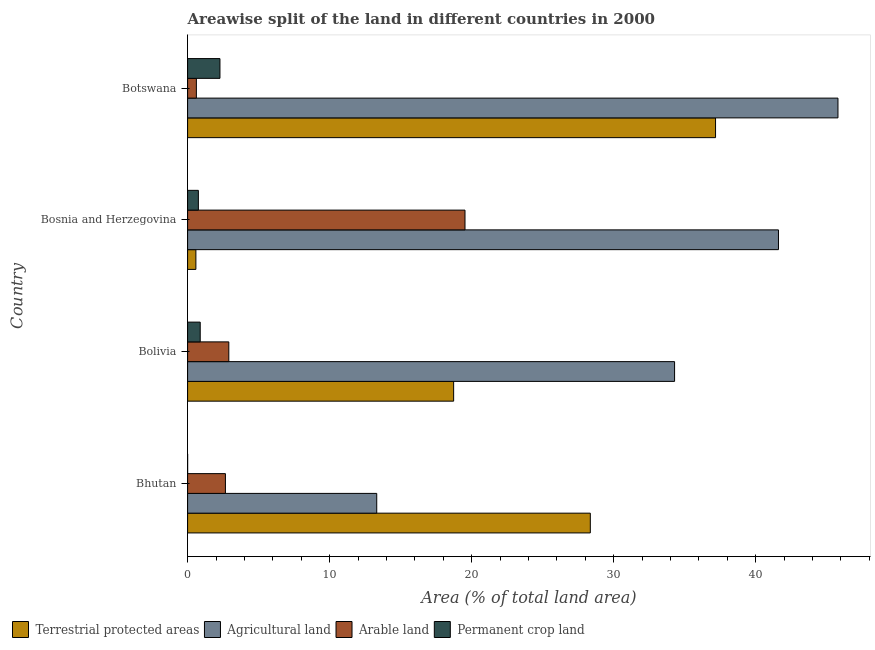How many different coloured bars are there?
Offer a terse response. 4. Are the number of bars on each tick of the Y-axis equal?
Keep it short and to the point. Yes. How many bars are there on the 1st tick from the top?
Ensure brevity in your answer.  4. How many bars are there on the 3rd tick from the bottom?
Your response must be concise. 4. What is the label of the 4th group of bars from the top?
Offer a terse response. Bhutan. In how many cases, is the number of bars for a given country not equal to the number of legend labels?
Provide a short and direct response. 0. What is the percentage of area under agricultural land in Bhutan?
Your answer should be compact. 13.32. Across all countries, what is the maximum percentage of area under permanent crop land?
Your answer should be very brief. 2.28. Across all countries, what is the minimum percentage of area under permanent crop land?
Your answer should be compact. 0. In which country was the percentage of area under arable land maximum?
Keep it short and to the point. Bosnia and Herzegovina. In which country was the percentage of area under agricultural land minimum?
Ensure brevity in your answer.  Bhutan. What is the total percentage of area under agricultural land in the graph?
Keep it short and to the point. 135. What is the difference between the percentage of area under agricultural land in Bolivia and that in Bosnia and Herzegovina?
Your answer should be compact. -7.32. What is the difference between the percentage of area under agricultural land in Bosnia and Herzegovina and the percentage of area under arable land in Bolivia?
Provide a succinct answer. 38.7. What is the average percentage of area under arable land per country?
Your answer should be compact. 6.43. What is the difference between the percentage of land under terrestrial protection and percentage of area under arable land in Bolivia?
Your answer should be very brief. 15.83. What is the ratio of the percentage of land under terrestrial protection in Bolivia to that in Botswana?
Give a very brief answer. 0.5. Is the percentage of area under agricultural land in Bolivia less than that in Bosnia and Herzegovina?
Give a very brief answer. Yes. What is the difference between the highest and the second highest percentage of area under agricultural land?
Offer a very short reply. 4.19. What is the difference between the highest and the lowest percentage of area under arable land?
Give a very brief answer. 18.91. Is the sum of the percentage of area under arable land in Bolivia and Bosnia and Herzegovina greater than the maximum percentage of land under terrestrial protection across all countries?
Ensure brevity in your answer.  No. What does the 2nd bar from the top in Bolivia represents?
Offer a terse response. Arable land. What does the 4th bar from the bottom in Bhutan represents?
Provide a succinct answer. Permanent crop land. Are all the bars in the graph horizontal?
Keep it short and to the point. Yes. Are the values on the major ticks of X-axis written in scientific E-notation?
Provide a succinct answer. No. What is the title of the graph?
Make the answer very short. Areawise split of the land in different countries in 2000. What is the label or title of the X-axis?
Make the answer very short. Area (% of total land area). What is the Area (% of total land area) in Terrestrial protected areas in Bhutan?
Your answer should be very brief. 28.35. What is the Area (% of total land area) of Agricultural land in Bhutan?
Your response must be concise. 13.32. What is the Area (% of total land area) in Arable land in Bhutan?
Provide a short and direct response. 2.66. What is the Area (% of total land area) in Permanent crop land in Bhutan?
Make the answer very short. 0. What is the Area (% of total land area) of Terrestrial protected areas in Bolivia?
Provide a succinct answer. 18.73. What is the Area (% of total land area) of Agricultural land in Bolivia?
Your answer should be compact. 34.29. What is the Area (% of total land area) in Arable land in Bolivia?
Keep it short and to the point. 2.9. What is the Area (% of total land area) of Permanent crop land in Bolivia?
Keep it short and to the point. 0.89. What is the Area (% of total land area) of Terrestrial protected areas in Bosnia and Herzegovina?
Your answer should be compact. 0.58. What is the Area (% of total land area) in Agricultural land in Bosnia and Herzegovina?
Provide a succinct answer. 41.6. What is the Area (% of total land area) of Arable land in Bosnia and Herzegovina?
Your answer should be compact. 19.53. What is the Area (% of total land area) in Permanent crop land in Bosnia and Herzegovina?
Your answer should be compact. 0.76. What is the Area (% of total land area) of Terrestrial protected areas in Botswana?
Keep it short and to the point. 37.17. What is the Area (% of total land area) of Agricultural land in Botswana?
Your answer should be compact. 45.79. What is the Area (% of total land area) of Arable land in Botswana?
Offer a terse response. 0.62. What is the Area (% of total land area) of Permanent crop land in Botswana?
Provide a succinct answer. 2.28. Across all countries, what is the maximum Area (% of total land area) in Terrestrial protected areas?
Offer a very short reply. 37.17. Across all countries, what is the maximum Area (% of total land area) in Agricultural land?
Your answer should be compact. 45.79. Across all countries, what is the maximum Area (% of total land area) of Arable land?
Your answer should be very brief. 19.53. Across all countries, what is the maximum Area (% of total land area) of Permanent crop land?
Keep it short and to the point. 2.28. Across all countries, what is the minimum Area (% of total land area) in Terrestrial protected areas?
Ensure brevity in your answer.  0.58. Across all countries, what is the minimum Area (% of total land area) in Agricultural land?
Your answer should be compact. 13.32. Across all countries, what is the minimum Area (% of total land area) of Arable land?
Ensure brevity in your answer.  0.62. Across all countries, what is the minimum Area (% of total land area) in Permanent crop land?
Make the answer very short. 0. What is the total Area (% of total land area) of Terrestrial protected areas in the graph?
Your answer should be compact. 84.84. What is the total Area (% of total land area) of Agricultural land in the graph?
Your answer should be compact. 135. What is the total Area (% of total land area) in Arable land in the graph?
Provide a succinct answer. 25.71. What is the total Area (% of total land area) in Permanent crop land in the graph?
Offer a terse response. 3.93. What is the difference between the Area (% of total land area) in Terrestrial protected areas in Bhutan and that in Bolivia?
Provide a succinct answer. 9.62. What is the difference between the Area (% of total land area) in Agricultural land in Bhutan and that in Bolivia?
Ensure brevity in your answer.  -20.97. What is the difference between the Area (% of total land area) in Arable land in Bhutan and that in Bolivia?
Give a very brief answer. -0.24. What is the difference between the Area (% of total land area) in Permanent crop land in Bhutan and that in Bolivia?
Your answer should be compact. -0.89. What is the difference between the Area (% of total land area) of Terrestrial protected areas in Bhutan and that in Bosnia and Herzegovina?
Provide a short and direct response. 27.77. What is the difference between the Area (% of total land area) in Agricultural land in Bhutan and that in Bosnia and Herzegovina?
Offer a terse response. -28.29. What is the difference between the Area (% of total land area) of Arable land in Bhutan and that in Bosnia and Herzegovina?
Make the answer very short. -16.87. What is the difference between the Area (% of total land area) of Permanent crop land in Bhutan and that in Bosnia and Herzegovina?
Provide a succinct answer. -0.76. What is the difference between the Area (% of total land area) in Terrestrial protected areas in Bhutan and that in Botswana?
Your answer should be very brief. -8.82. What is the difference between the Area (% of total land area) of Agricultural land in Bhutan and that in Botswana?
Ensure brevity in your answer.  -32.47. What is the difference between the Area (% of total land area) in Arable land in Bhutan and that in Botswana?
Provide a succinct answer. 2.05. What is the difference between the Area (% of total land area) of Permanent crop land in Bhutan and that in Botswana?
Your response must be concise. -2.28. What is the difference between the Area (% of total land area) in Terrestrial protected areas in Bolivia and that in Bosnia and Herzegovina?
Ensure brevity in your answer.  18.15. What is the difference between the Area (% of total land area) of Agricultural land in Bolivia and that in Bosnia and Herzegovina?
Your answer should be very brief. -7.31. What is the difference between the Area (% of total land area) in Arable land in Bolivia and that in Bosnia and Herzegovina?
Your answer should be compact. -16.63. What is the difference between the Area (% of total land area) of Permanent crop land in Bolivia and that in Bosnia and Herzegovina?
Ensure brevity in your answer.  0.13. What is the difference between the Area (% of total land area) of Terrestrial protected areas in Bolivia and that in Botswana?
Offer a very short reply. -18.44. What is the difference between the Area (% of total land area) of Agricultural land in Bolivia and that in Botswana?
Ensure brevity in your answer.  -11.5. What is the difference between the Area (% of total land area) of Arable land in Bolivia and that in Botswana?
Ensure brevity in your answer.  2.28. What is the difference between the Area (% of total land area) of Permanent crop land in Bolivia and that in Botswana?
Ensure brevity in your answer.  -1.39. What is the difference between the Area (% of total land area) of Terrestrial protected areas in Bosnia and Herzegovina and that in Botswana?
Offer a terse response. -36.59. What is the difference between the Area (% of total land area) of Agricultural land in Bosnia and Herzegovina and that in Botswana?
Make the answer very short. -4.19. What is the difference between the Area (% of total land area) in Arable land in Bosnia and Herzegovina and that in Botswana?
Provide a short and direct response. 18.91. What is the difference between the Area (% of total land area) of Permanent crop land in Bosnia and Herzegovina and that in Botswana?
Ensure brevity in your answer.  -1.52. What is the difference between the Area (% of total land area) in Terrestrial protected areas in Bhutan and the Area (% of total land area) in Agricultural land in Bolivia?
Keep it short and to the point. -5.93. What is the difference between the Area (% of total land area) in Terrestrial protected areas in Bhutan and the Area (% of total land area) in Arable land in Bolivia?
Keep it short and to the point. 25.45. What is the difference between the Area (% of total land area) of Terrestrial protected areas in Bhutan and the Area (% of total land area) of Permanent crop land in Bolivia?
Offer a very short reply. 27.47. What is the difference between the Area (% of total land area) in Agricultural land in Bhutan and the Area (% of total land area) in Arable land in Bolivia?
Keep it short and to the point. 10.41. What is the difference between the Area (% of total land area) in Agricultural land in Bhutan and the Area (% of total land area) in Permanent crop land in Bolivia?
Provide a short and direct response. 12.43. What is the difference between the Area (% of total land area) in Arable land in Bhutan and the Area (% of total land area) in Permanent crop land in Bolivia?
Ensure brevity in your answer.  1.78. What is the difference between the Area (% of total land area) in Terrestrial protected areas in Bhutan and the Area (% of total land area) in Agricultural land in Bosnia and Herzegovina?
Give a very brief answer. -13.25. What is the difference between the Area (% of total land area) in Terrestrial protected areas in Bhutan and the Area (% of total land area) in Arable land in Bosnia and Herzegovina?
Give a very brief answer. 8.82. What is the difference between the Area (% of total land area) of Terrestrial protected areas in Bhutan and the Area (% of total land area) of Permanent crop land in Bosnia and Herzegovina?
Ensure brevity in your answer.  27.6. What is the difference between the Area (% of total land area) of Agricultural land in Bhutan and the Area (% of total land area) of Arable land in Bosnia and Herzegovina?
Provide a succinct answer. -6.21. What is the difference between the Area (% of total land area) in Agricultural land in Bhutan and the Area (% of total land area) in Permanent crop land in Bosnia and Herzegovina?
Your answer should be compact. 12.56. What is the difference between the Area (% of total land area) of Arable land in Bhutan and the Area (% of total land area) of Permanent crop land in Bosnia and Herzegovina?
Offer a terse response. 1.9. What is the difference between the Area (% of total land area) in Terrestrial protected areas in Bhutan and the Area (% of total land area) in Agricultural land in Botswana?
Give a very brief answer. -17.44. What is the difference between the Area (% of total land area) of Terrestrial protected areas in Bhutan and the Area (% of total land area) of Arable land in Botswana?
Make the answer very short. 27.74. What is the difference between the Area (% of total land area) of Terrestrial protected areas in Bhutan and the Area (% of total land area) of Permanent crop land in Botswana?
Make the answer very short. 26.08. What is the difference between the Area (% of total land area) in Agricultural land in Bhutan and the Area (% of total land area) in Arable land in Botswana?
Give a very brief answer. 12.7. What is the difference between the Area (% of total land area) in Agricultural land in Bhutan and the Area (% of total land area) in Permanent crop land in Botswana?
Offer a very short reply. 11.04. What is the difference between the Area (% of total land area) in Arable land in Bhutan and the Area (% of total land area) in Permanent crop land in Botswana?
Your answer should be very brief. 0.39. What is the difference between the Area (% of total land area) of Terrestrial protected areas in Bolivia and the Area (% of total land area) of Agricultural land in Bosnia and Herzegovina?
Offer a terse response. -22.87. What is the difference between the Area (% of total land area) of Terrestrial protected areas in Bolivia and the Area (% of total land area) of Permanent crop land in Bosnia and Herzegovina?
Your response must be concise. 17.97. What is the difference between the Area (% of total land area) of Agricultural land in Bolivia and the Area (% of total land area) of Arable land in Bosnia and Herzegovina?
Your answer should be very brief. 14.76. What is the difference between the Area (% of total land area) in Agricultural land in Bolivia and the Area (% of total land area) in Permanent crop land in Bosnia and Herzegovina?
Your response must be concise. 33.53. What is the difference between the Area (% of total land area) of Arable land in Bolivia and the Area (% of total land area) of Permanent crop land in Bosnia and Herzegovina?
Ensure brevity in your answer.  2.14. What is the difference between the Area (% of total land area) of Terrestrial protected areas in Bolivia and the Area (% of total land area) of Agricultural land in Botswana?
Make the answer very short. -27.06. What is the difference between the Area (% of total land area) of Terrestrial protected areas in Bolivia and the Area (% of total land area) of Arable land in Botswana?
Your answer should be very brief. 18.11. What is the difference between the Area (% of total land area) in Terrestrial protected areas in Bolivia and the Area (% of total land area) in Permanent crop land in Botswana?
Offer a terse response. 16.45. What is the difference between the Area (% of total land area) of Agricultural land in Bolivia and the Area (% of total land area) of Arable land in Botswana?
Give a very brief answer. 33.67. What is the difference between the Area (% of total land area) in Agricultural land in Bolivia and the Area (% of total land area) in Permanent crop land in Botswana?
Keep it short and to the point. 32.01. What is the difference between the Area (% of total land area) of Arable land in Bolivia and the Area (% of total land area) of Permanent crop land in Botswana?
Keep it short and to the point. 0.62. What is the difference between the Area (% of total land area) in Terrestrial protected areas in Bosnia and Herzegovina and the Area (% of total land area) in Agricultural land in Botswana?
Give a very brief answer. -45.21. What is the difference between the Area (% of total land area) in Terrestrial protected areas in Bosnia and Herzegovina and the Area (% of total land area) in Arable land in Botswana?
Give a very brief answer. -0.03. What is the difference between the Area (% of total land area) in Terrestrial protected areas in Bosnia and Herzegovina and the Area (% of total land area) in Permanent crop land in Botswana?
Your answer should be compact. -1.69. What is the difference between the Area (% of total land area) in Agricultural land in Bosnia and Herzegovina and the Area (% of total land area) in Arable land in Botswana?
Offer a terse response. 40.98. What is the difference between the Area (% of total land area) of Agricultural land in Bosnia and Herzegovina and the Area (% of total land area) of Permanent crop land in Botswana?
Offer a very short reply. 39.32. What is the difference between the Area (% of total land area) of Arable land in Bosnia and Herzegovina and the Area (% of total land area) of Permanent crop land in Botswana?
Offer a terse response. 17.25. What is the average Area (% of total land area) in Terrestrial protected areas per country?
Provide a short and direct response. 21.21. What is the average Area (% of total land area) in Agricultural land per country?
Your answer should be compact. 33.75. What is the average Area (% of total land area) of Arable land per country?
Offer a terse response. 6.43. What is the average Area (% of total land area) of Permanent crop land per country?
Keep it short and to the point. 0.98. What is the difference between the Area (% of total land area) in Terrestrial protected areas and Area (% of total land area) in Agricultural land in Bhutan?
Make the answer very short. 15.04. What is the difference between the Area (% of total land area) in Terrestrial protected areas and Area (% of total land area) in Arable land in Bhutan?
Your answer should be very brief. 25.69. What is the difference between the Area (% of total land area) of Terrestrial protected areas and Area (% of total land area) of Permanent crop land in Bhutan?
Make the answer very short. 28.35. What is the difference between the Area (% of total land area) in Agricultural land and Area (% of total land area) in Arable land in Bhutan?
Offer a very short reply. 10.65. What is the difference between the Area (% of total land area) of Agricultural land and Area (% of total land area) of Permanent crop land in Bhutan?
Give a very brief answer. 13.31. What is the difference between the Area (% of total land area) of Arable land and Area (% of total land area) of Permanent crop land in Bhutan?
Keep it short and to the point. 2.66. What is the difference between the Area (% of total land area) in Terrestrial protected areas and Area (% of total land area) in Agricultural land in Bolivia?
Make the answer very short. -15.56. What is the difference between the Area (% of total land area) of Terrestrial protected areas and Area (% of total land area) of Arable land in Bolivia?
Offer a terse response. 15.83. What is the difference between the Area (% of total land area) of Terrestrial protected areas and Area (% of total land area) of Permanent crop land in Bolivia?
Your answer should be compact. 17.84. What is the difference between the Area (% of total land area) in Agricultural land and Area (% of total land area) in Arable land in Bolivia?
Keep it short and to the point. 31.38. What is the difference between the Area (% of total land area) of Agricultural land and Area (% of total land area) of Permanent crop land in Bolivia?
Provide a short and direct response. 33.4. What is the difference between the Area (% of total land area) of Arable land and Area (% of total land area) of Permanent crop land in Bolivia?
Give a very brief answer. 2.01. What is the difference between the Area (% of total land area) in Terrestrial protected areas and Area (% of total land area) in Agricultural land in Bosnia and Herzegovina?
Make the answer very short. -41.02. What is the difference between the Area (% of total land area) of Terrestrial protected areas and Area (% of total land area) of Arable land in Bosnia and Herzegovina?
Give a very brief answer. -18.95. What is the difference between the Area (% of total land area) in Terrestrial protected areas and Area (% of total land area) in Permanent crop land in Bosnia and Herzegovina?
Your answer should be compact. -0.18. What is the difference between the Area (% of total land area) of Agricultural land and Area (% of total land area) of Arable land in Bosnia and Herzegovina?
Give a very brief answer. 22.07. What is the difference between the Area (% of total land area) of Agricultural land and Area (% of total land area) of Permanent crop land in Bosnia and Herzegovina?
Provide a short and direct response. 40.84. What is the difference between the Area (% of total land area) in Arable land and Area (% of total land area) in Permanent crop land in Bosnia and Herzegovina?
Ensure brevity in your answer.  18.77. What is the difference between the Area (% of total land area) in Terrestrial protected areas and Area (% of total land area) in Agricultural land in Botswana?
Provide a succinct answer. -8.62. What is the difference between the Area (% of total land area) of Terrestrial protected areas and Area (% of total land area) of Arable land in Botswana?
Provide a succinct answer. 36.55. What is the difference between the Area (% of total land area) in Terrestrial protected areas and Area (% of total land area) in Permanent crop land in Botswana?
Provide a short and direct response. 34.89. What is the difference between the Area (% of total land area) of Agricultural land and Area (% of total land area) of Arable land in Botswana?
Offer a terse response. 45.17. What is the difference between the Area (% of total land area) in Agricultural land and Area (% of total land area) in Permanent crop land in Botswana?
Offer a very short reply. 43.51. What is the difference between the Area (% of total land area) of Arable land and Area (% of total land area) of Permanent crop land in Botswana?
Your response must be concise. -1.66. What is the ratio of the Area (% of total land area) of Terrestrial protected areas in Bhutan to that in Bolivia?
Make the answer very short. 1.51. What is the ratio of the Area (% of total land area) in Agricultural land in Bhutan to that in Bolivia?
Your answer should be compact. 0.39. What is the ratio of the Area (% of total land area) in Arable land in Bhutan to that in Bolivia?
Make the answer very short. 0.92. What is the ratio of the Area (% of total land area) of Permanent crop land in Bhutan to that in Bolivia?
Make the answer very short. 0. What is the ratio of the Area (% of total land area) in Terrestrial protected areas in Bhutan to that in Bosnia and Herzegovina?
Provide a succinct answer. 48.59. What is the ratio of the Area (% of total land area) of Agricultural land in Bhutan to that in Bosnia and Herzegovina?
Keep it short and to the point. 0.32. What is the ratio of the Area (% of total land area) in Arable land in Bhutan to that in Bosnia and Herzegovina?
Provide a short and direct response. 0.14. What is the ratio of the Area (% of total land area) in Permanent crop land in Bhutan to that in Bosnia and Herzegovina?
Offer a very short reply. 0. What is the ratio of the Area (% of total land area) of Terrestrial protected areas in Bhutan to that in Botswana?
Offer a very short reply. 0.76. What is the ratio of the Area (% of total land area) in Agricultural land in Bhutan to that in Botswana?
Your response must be concise. 0.29. What is the ratio of the Area (% of total land area) of Arable land in Bhutan to that in Botswana?
Offer a terse response. 4.31. What is the ratio of the Area (% of total land area) in Permanent crop land in Bhutan to that in Botswana?
Your answer should be very brief. 0. What is the ratio of the Area (% of total land area) in Terrestrial protected areas in Bolivia to that in Bosnia and Herzegovina?
Your answer should be compact. 32.1. What is the ratio of the Area (% of total land area) of Agricultural land in Bolivia to that in Bosnia and Herzegovina?
Your answer should be compact. 0.82. What is the ratio of the Area (% of total land area) in Arable land in Bolivia to that in Bosnia and Herzegovina?
Make the answer very short. 0.15. What is the ratio of the Area (% of total land area) of Permanent crop land in Bolivia to that in Bosnia and Herzegovina?
Make the answer very short. 1.17. What is the ratio of the Area (% of total land area) in Terrestrial protected areas in Bolivia to that in Botswana?
Your response must be concise. 0.5. What is the ratio of the Area (% of total land area) of Agricultural land in Bolivia to that in Botswana?
Your response must be concise. 0.75. What is the ratio of the Area (% of total land area) of Arable land in Bolivia to that in Botswana?
Your response must be concise. 4.7. What is the ratio of the Area (% of total land area) in Permanent crop land in Bolivia to that in Botswana?
Give a very brief answer. 0.39. What is the ratio of the Area (% of total land area) in Terrestrial protected areas in Bosnia and Herzegovina to that in Botswana?
Offer a terse response. 0.02. What is the ratio of the Area (% of total land area) in Agricultural land in Bosnia and Herzegovina to that in Botswana?
Offer a terse response. 0.91. What is the ratio of the Area (% of total land area) in Arable land in Bosnia and Herzegovina to that in Botswana?
Your answer should be very brief. 31.63. What is the ratio of the Area (% of total land area) of Permanent crop land in Bosnia and Herzegovina to that in Botswana?
Keep it short and to the point. 0.33. What is the difference between the highest and the second highest Area (% of total land area) of Terrestrial protected areas?
Keep it short and to the point. 8.82. What is the difference between the highest and the second highest Area (% of total land area) of Agricultural land?
Offer a very short reply. 4.19. What is the difference between the highest and the second highest Area (% of total land area) of Arable land?
Your answer should be compact. 16.63. What is the difference between the highest and the second highest Area (% of total land area) in Permanent crop land?
Make the answer very short. 1.39. What is the difference between the highest and the lowest Area (% of total land area) in Terrestrial protected areas?
Your answer should be very brief. 36.59. What is the difference between the highest and the lowest Area (% of total land area) in Agricultural land?
Keep it short and to the point. 32.47. What is the difference between the highest and the lowest Area (% of total land area) of Arable land?
Keep it short and to the point. 18.91. What is the difference between the highest and the lowest Area (% of total land area) in Permanent crop land?
Provide a succinct answer. 2.28. 